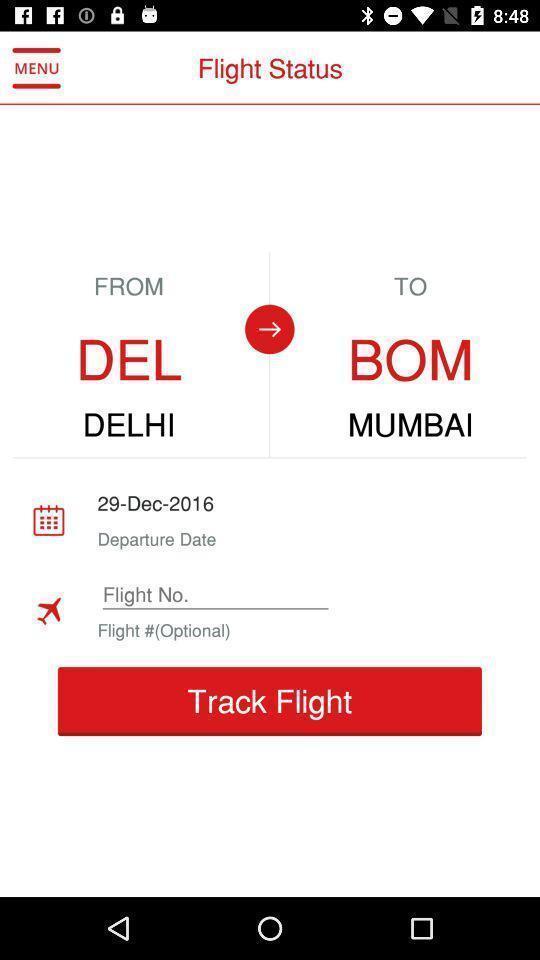What details can you identify in this image? Status of the flight which you booked. 